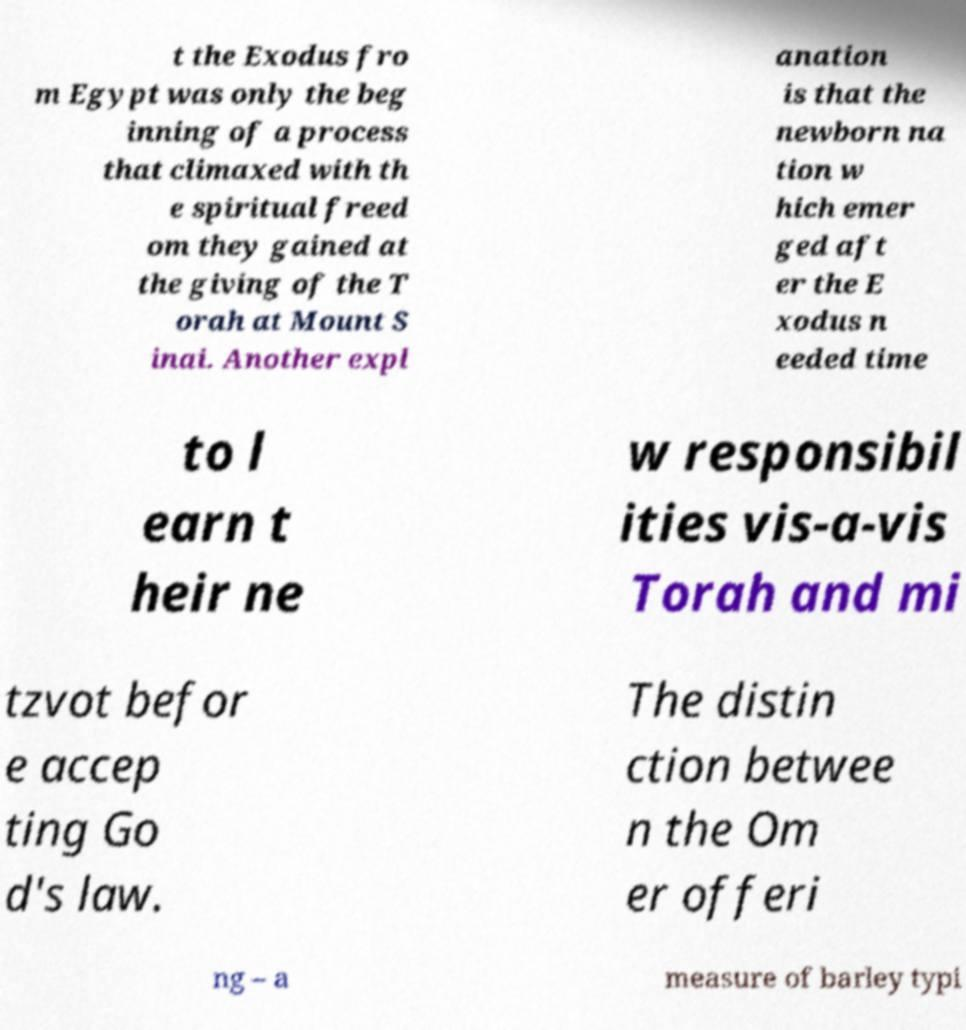Can you read and provide the text displayed in the image?This photo seems to have some interesting text. Can you extract and type it out for me? t the Exodus fro m Egypt was only the beg inning of a process that climaxed with th e spiritual freed om they gained at the giving of the T orah at Mount S inai. Another expl anation is that the newborn na tion w hich emer ged aft er the E xodus n eeded time to l earn t heir ne w responsibil ities vis-a-vis Torah and mi tzvot befor e accep ting Go d's law. The distin ction betwee n the Om er offeri ng – a measure of barley typi 